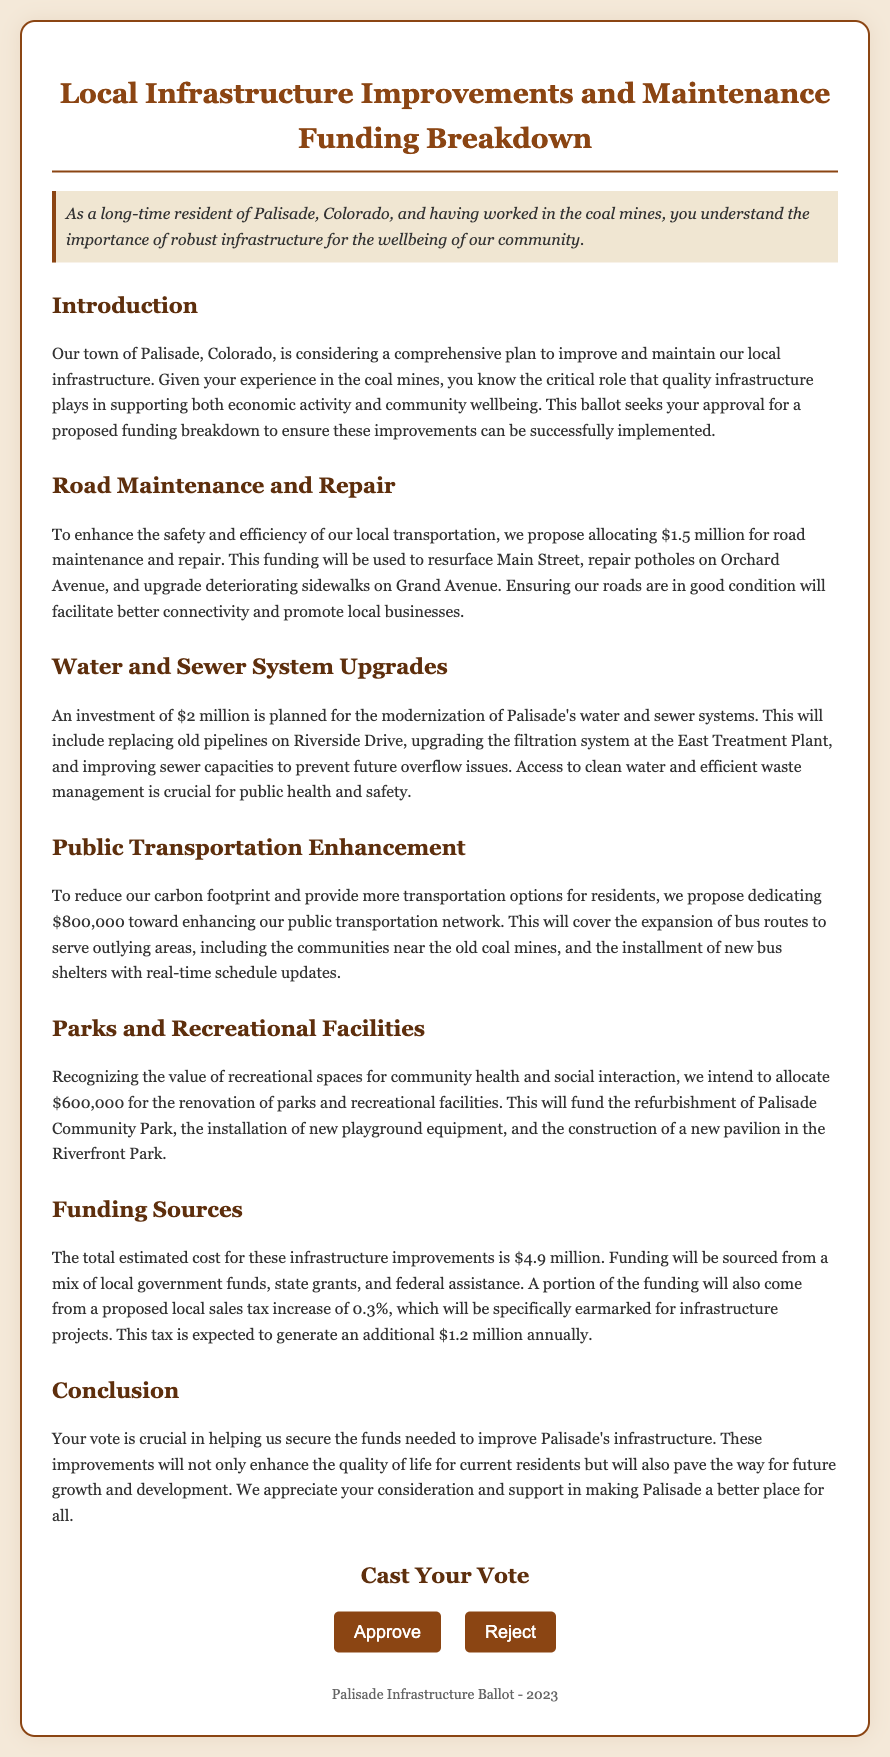What is the total cost of proposed infrastructure improvements? The total estimated cost for the infrastructure improvements is listed as $4.9 million in the document.
Answer: $4.9 million How much is allocated for road maintenance and repair? The document specifies an allocation of $1.5 million for road maintenance and repair.
Answer: $1.5 million What is the proposed local sales tax increase percentage? The proposed local sales tax increase mentioned in the document is 0.3%.
Answer: 0.3% What will the $600,000 funding for parks and recreational facilities cover? The funding will cover the refurbishment of Palisade Community Park, the installation of new playground equipment, and the construction of a new pavilion in Riverfront Park.
Answer: Refurbishment of parks, playground equipment, pavilion construction What is the amount proposed for public transportation enhancement? According to the document, $800,000 is proposed for enhancing public transportation.
Answer: $800,000 What is the main reason for upgrading the water and sewer systems? The document states that upgrading these systems is crucial for public health and safety.
Answer: Public health and safety How will the funding for these infrastructure improvements be sourced? The funding will come from local government funds, state grants, federal assistance, and a proposed local sales tax increase.
Answer: Local government funds, state grants, federal assistance, local sales tax increase What specific improvement is planned for Main Street? The improvement planned for Main Street is resurfacing.
Answer: Resurfacing 